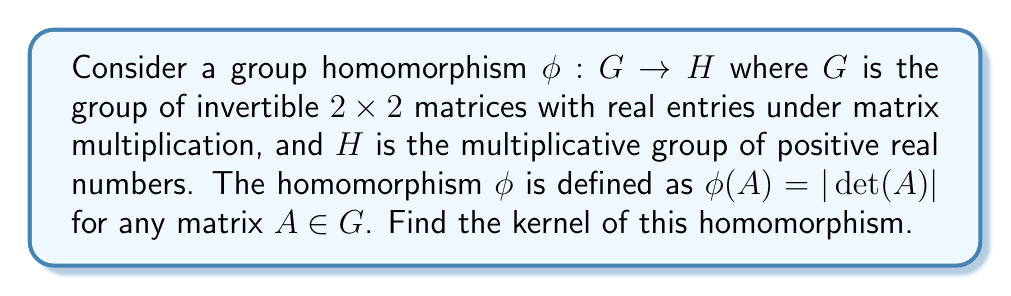Give your solution to this math problem. To find the kernel of the group homomorphism $\phi$, we need to determine all elements in $G$ that map to the identity element in $H$.

1) The identity element in $H$ (the multiplicative group of positive real numbers) is 1.

2) So, we need to find all matrices $A \in G$ such that $\phi(A) = 1$.

3) By the definition of $\phi$, this means we need to find all matrices $A$ where $|\det(A)| = 1$.

4) The determinant of a $2 \times 2$ matrix $A = \begin{pmatrix} a & b \\ c & d \end{pmatrix}$ is given by $\det(A) = ad - bc$.

5) The condition $|\det(A)| = 1$ means that $\det(A) = \pm 1$.

6) Therefore, the kernel of $\phi$ consists of all $2 \times 2$ invertible matrices with determinant equal to either 1 or -1.

7) In linear algebra, matrices with determinant 1 are called special linear matrices, and the group of such matrices is denoted as $SL(2, \mathbb{R})$.

8) The kernel of $\phi$ includes both $SL(2, \mathbb{R})$ and its negative, $-SL(2, \mathbb{R})$.
Answer: The kernel of $\phi$ is the set of all $2 \times 2$ invertible real matrices with determinant equal to either 1 or -1. In group theory notation, this can be written as:

$$\text{ker}(\phi) = \{A \in GL(2, \mathbb{R}) : \det(A) = \pm 1\} = SL(2, \mathbb{R}) \cup (-SL(2, \mathbb{R}))$$ 